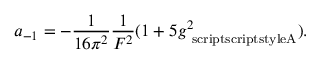Convert formula to latex. <formula><loc_0><loc_0><loc_500><loc_500>a _ { - 1 } = - \frac { 1 } { 1 6 \pi ^ { 2 } } \frac { 1 } { F ^ { 2 } } ( 1 + 5 g _ { \ s c r i p t s c r i p t s t y l e A } ^ { 2 } ) .</formula> 